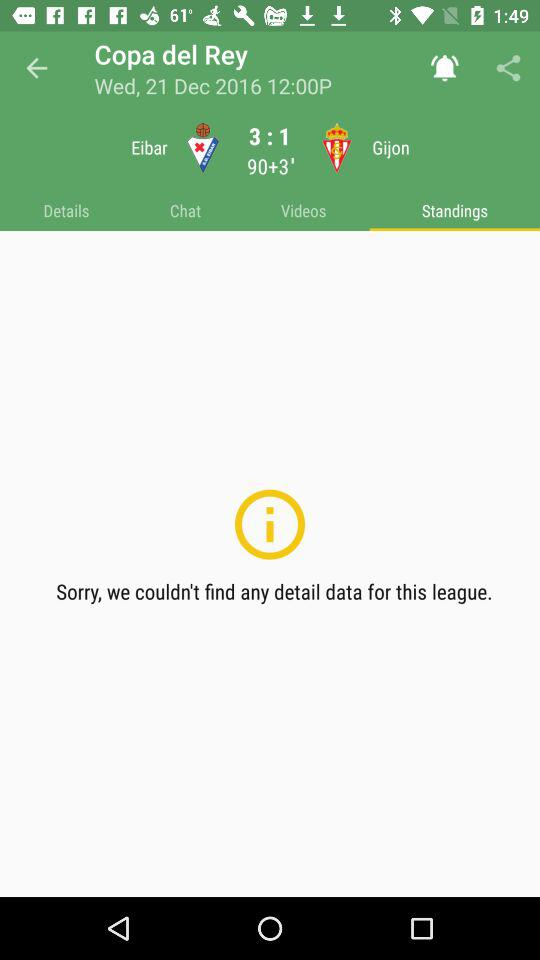What is the ration of Eliber of spain?
When the provided information is insufficient, respond with <no answer>. <no answer> 